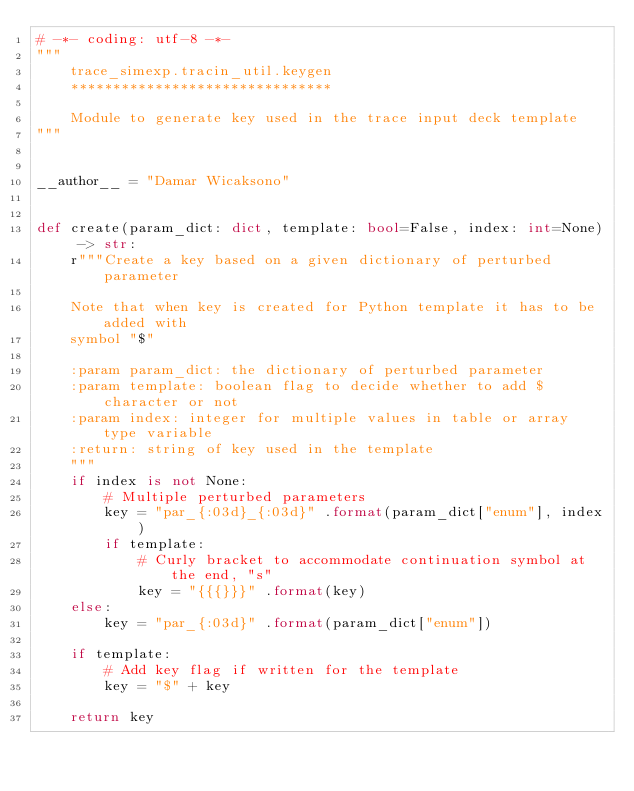Convert code to text. <code><loc_0><loc_0><loc_500><loc_500><_Python_># -*- coding: utf-8 -*-
"""
    trace_simexp.tracin_util.keygen
    *******************************

    Module to generate key used in the trace input deck template
"""


__author__ = "Damar Wicaksono"


def create(param_dict: dict, template: bool=False, index: int=None) -> str:
    r"""Create a key based on a given dictionary of perturbed parameter

    Note that when key is created for Python template it has to be added with
    symbol "$"
    
    :param param_dict: the dictionary of perturbed parameter
    :param template: boolean flag to decide whether to add $ character or not
    :param index: integer for multiple values in table or array type variable
    :return: string of key used in the template
    """
    if index is not None:
        # Multiple perturbed parameters
        key = "par_{:03d}_{:03d}" .format(param_dict["enum"], index)
        if template:
            # Curly bracket to accommodate continuation symbol at the end, "s"
            key = "{{{}}}" .format(key)
    else:
        key = "par_{:03d}" .format(param_dict["enum"])

    if template:
        # Add key flag if written for the template
        key = "$" + key

    return key
</code> 